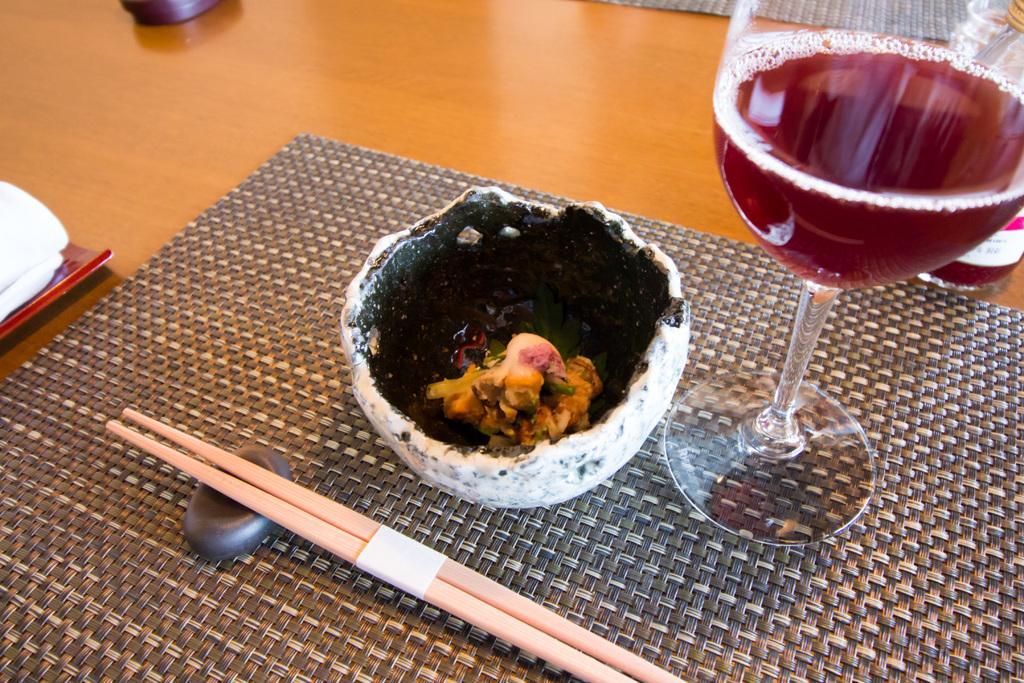Can you describe this image briefly? This is a picture on the table. On the foreground there is a mat, on the mat there is a bowl, chopsticks, and a drink. In the bowl there is food. In the background there is a box. On the left there is a plate. On the right there is a bottle. 